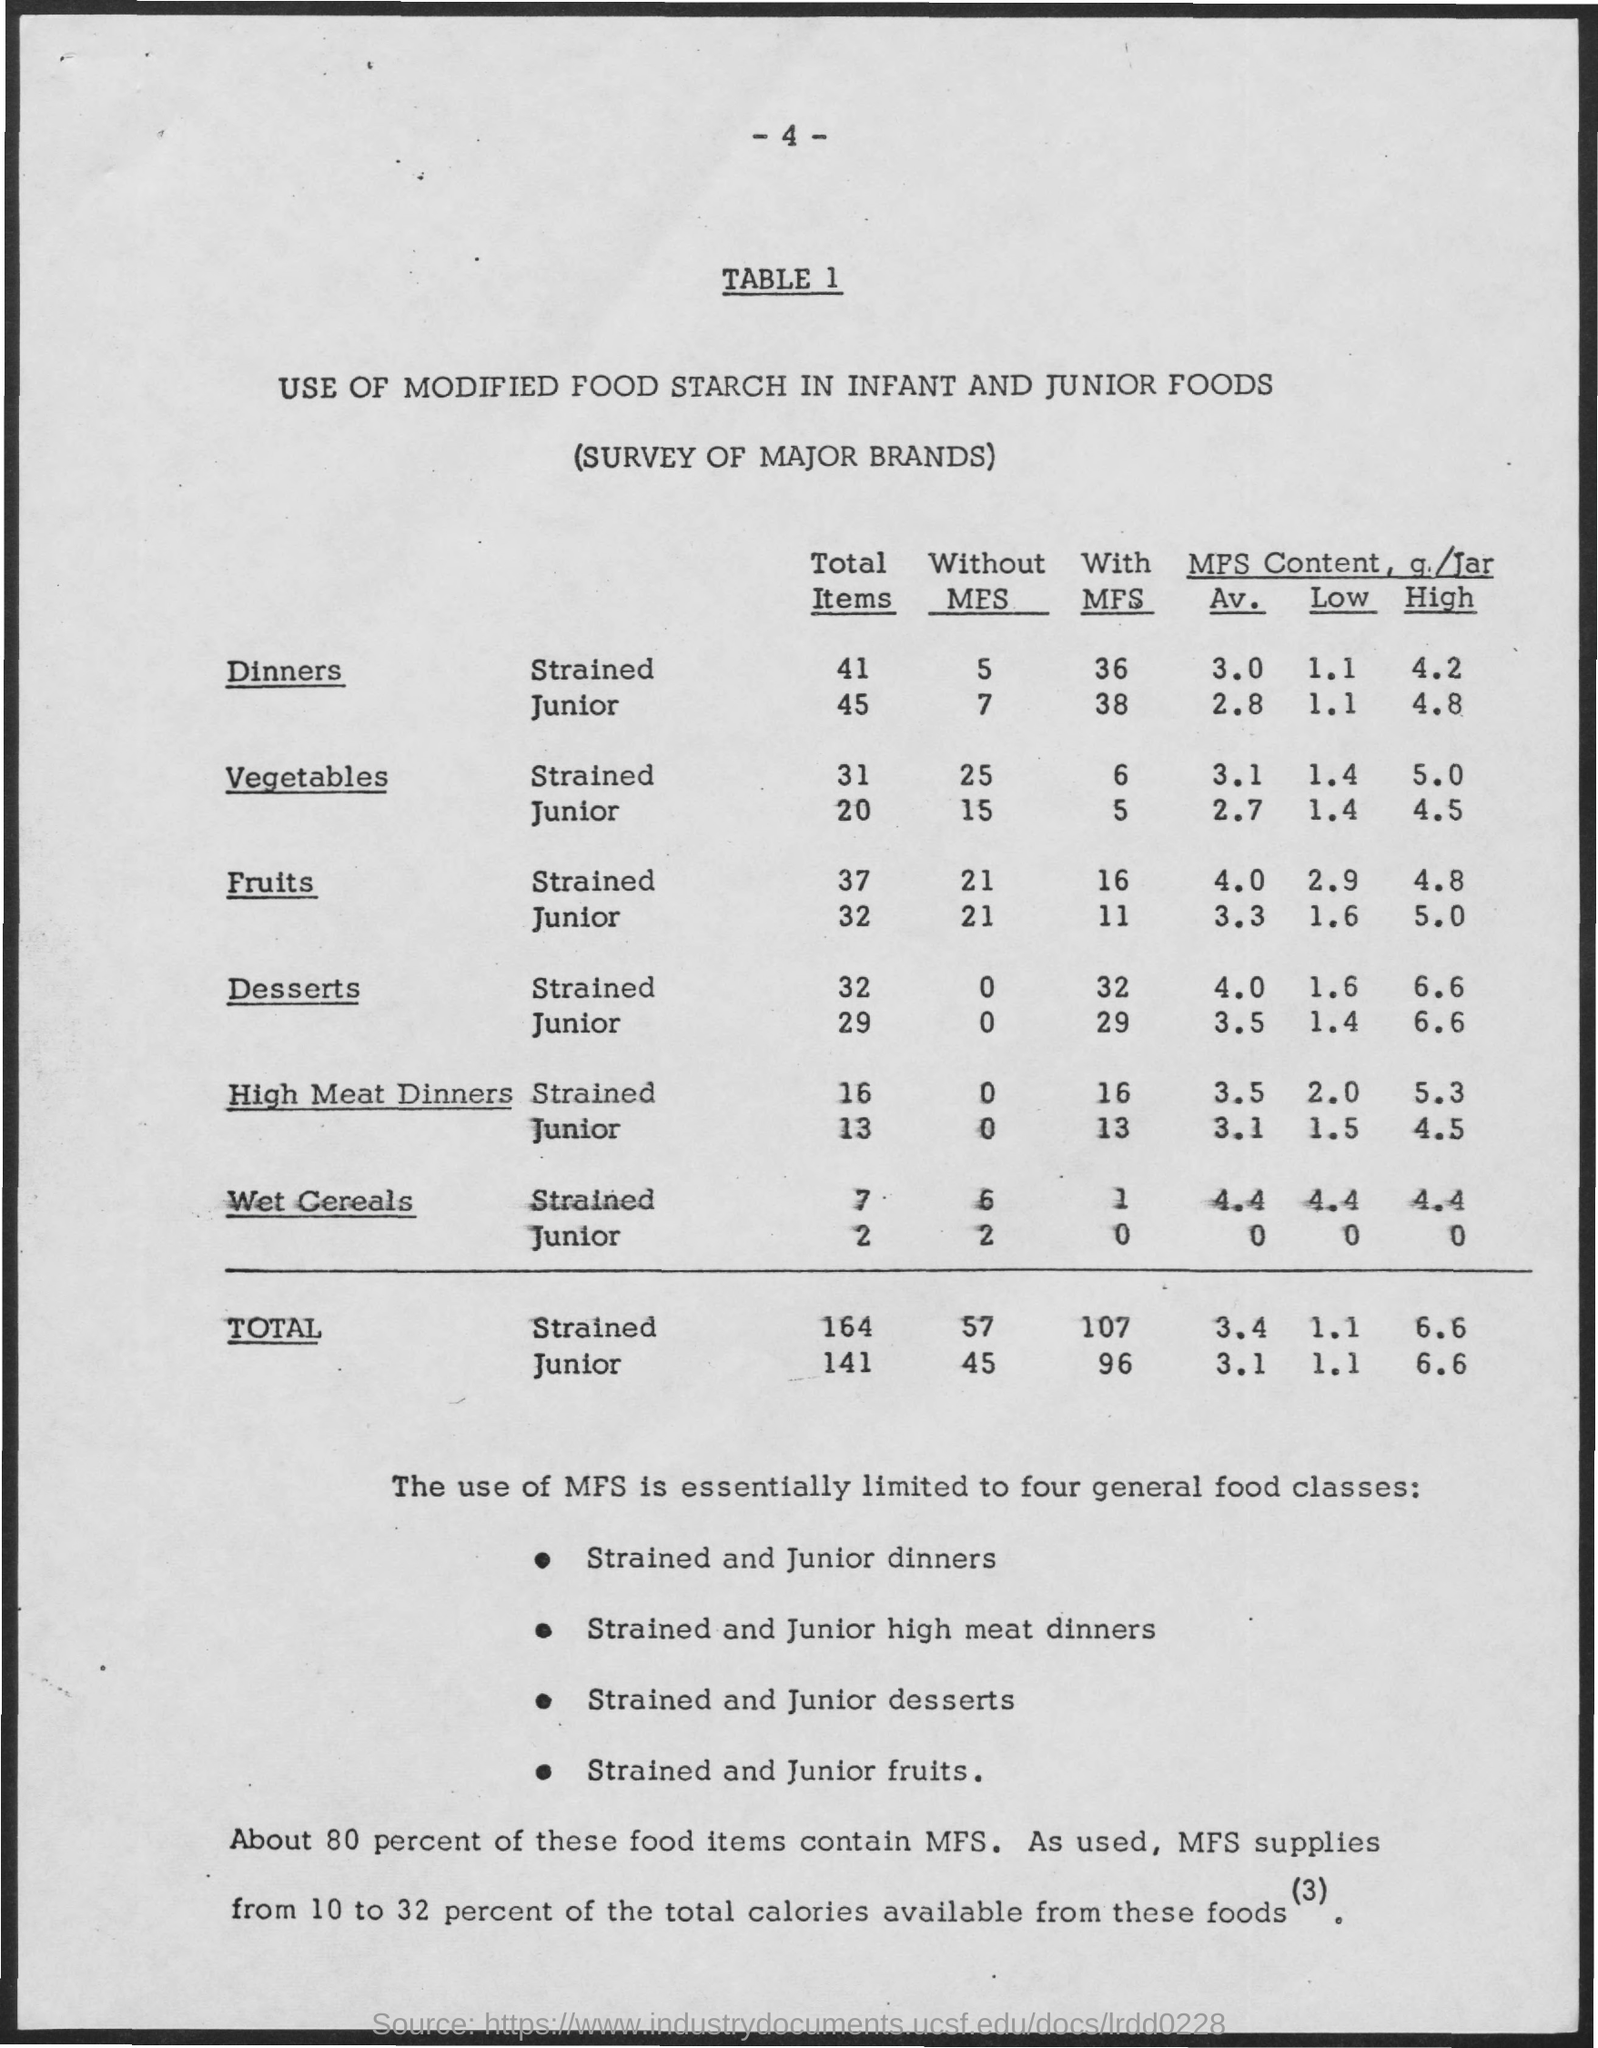Give some essential details in this illustration. What are the consequences of not using Multi-Factor Security (MFS) for strained dinners? What are the options for Junior Dinners without MFS? The junior vegetables without MFS are 15.. The total number of junior dinners is 45. The results of the study show that the MFS values for strained vegetables were 25 without MFS. 